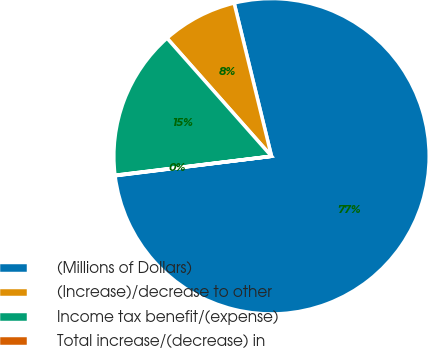Convert chart to OTSL. <chart><loc_0><loc_0><loc_500><loc_500><pie_chart><fcel>(Millions of Dollars)<fcel>(Increase)/decrease to other<fcel>Income tax benefit/(expense)<fcel>Total increase/(decrease) in<nl><fcel>76.84%<fcel>7.72%<fcel>15.4%<fcel>0.04%<nl></chart> 